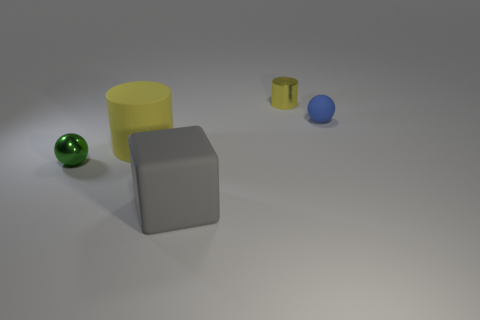The small rubber sphere that is behind the large block is what color?
Offer a very short reply. Blue. Is there a tiny blue rubber object that has the same shape as the small yellow metallic thing?
Your response must be concise. No. What is the blue thing made of?
Provide a succinct answer. Rubber. How big is the object that is both left of the small blue rubber object and behind the large cylinder?
Your answer should be very brief. Small. There is another cylinder that is the same color as the small metallic cylinder; what is it made of?
Make the answer very short. Rubber. How many tiny green metal things are there?
Provide a short and direct response. 1. Is the number of tiny green objects less than the number of big gray rubber balls?
Keep it short and to the point. No. There is a green sphere that is the same size as the shiny cylinder; what is it made of?
Keep it short and to the point. Metal. How many objects are brown metallic objects or tiny metallic spheres?
Give a very brief answer. 1. How many things are both in front of the large yellow thing and right of the large yellow cylinder?
Give a very brief answer. 1. 